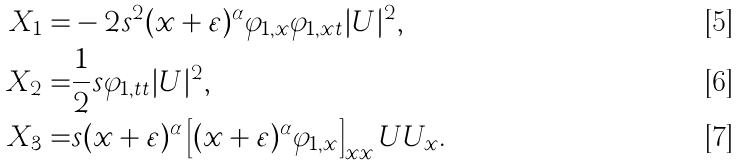<formula> <loc_0><loc_0><loc_500><loc_500>X _ { 1 } = & - 2 s ^ { 2 } ( x + \varepsilon ) ^ { \alpha } \varphi _ { 1 , x } \varphi _ { 1 , x t } | U | ^ { 2 } , \\ X _ { 2 } = & \frac { 1 } { 2 } s \varphi _ { 1 , t t } | U | ^ { 2 } , \\ X _ { 3 } = & s ( x + \varepsilon ) ^ { \alpha } \left [ ( x + \varepsilon ) ^ { \alpha } \varphi _ { 1 , x } \right ] _ { x x } U U _ { x } .</formula> 